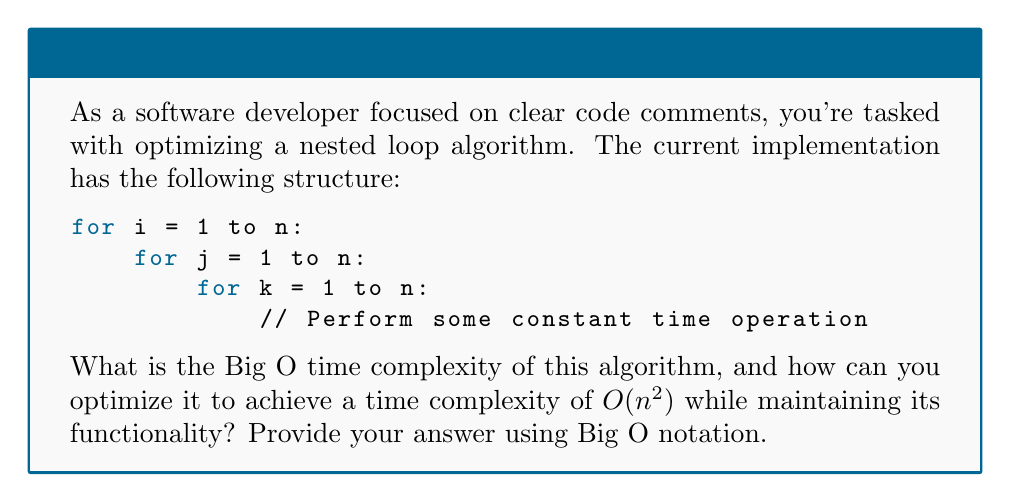Give your solution to this math problem. Let's approach this step-by-step:

1. Analyze the current time complexity:
   - The outermost loop runs $n$ times.
   - For each iteration of the outer loop, the middle loop runs $n$ times.
   - For each iteration of the middle loop, the innermost loop runs $n$ times.
   - The total number of operations is $n \times n \times n = n^3$.
   - Therefore, the current time complexity is $O(n^3)$.

2. To optimize this to $O(n^2)$, we need to eliminate one of the nested loops:
   - We can achieve this by combining two of the loops into a single loop.
   - This is possible if the operations inside the innermost loop can be restructured.

3. Optimized structure:
   ```
   for i = 1 to n:
       for j = 1 to n:
           // Perform the operation that was previously in the innermost loop
   ```

4. In the optimized version:
   - The outer loop runs $n$ times.
   - For each iteration of the outer loop, the inner loop runs $n$ times.
   - The total number of operations is $n \times n = n^2$.
   - This results in a time complexity of $O(n^2)$.

5. To maintain functionality:
   - Ensure that any dependencies on the original `k` variable are handled within the combined loop.
   - You may need to use arithmetic or logical operations to simulate the effect of the removed loop.

By restructuring the nested loops, we've reduced the time complexity from $O(n^3)$ to $O(n^2)$, achieving the desired optimization.
Answer: $O(n^3)$ → $O(n^2)$ 